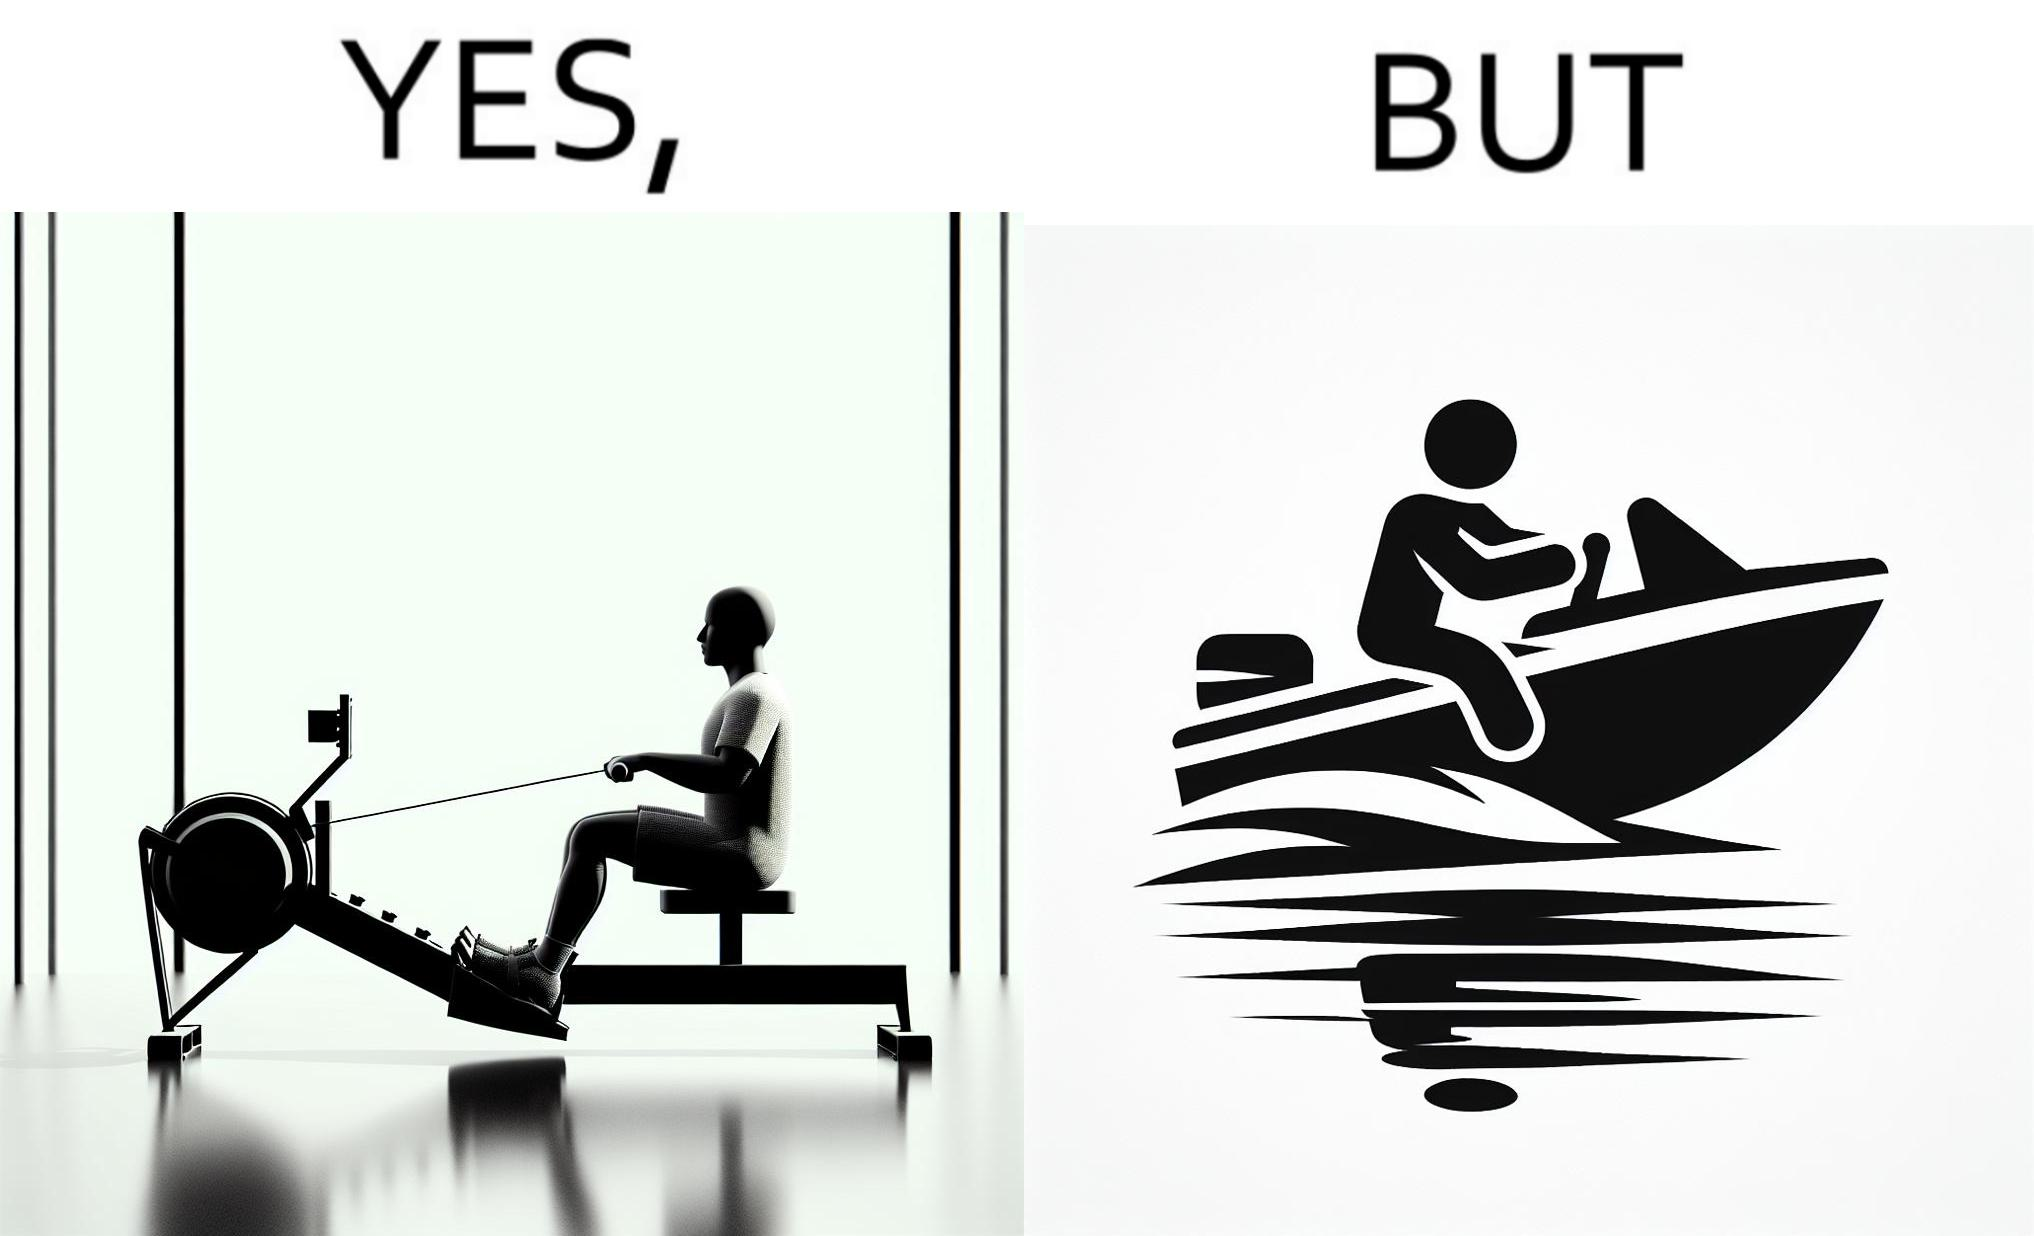What is shown in the left half versus the right half of this image? In the left part of the image: a person doing rowing exercise in gym In the right part of the image: a person riding a motorboat 